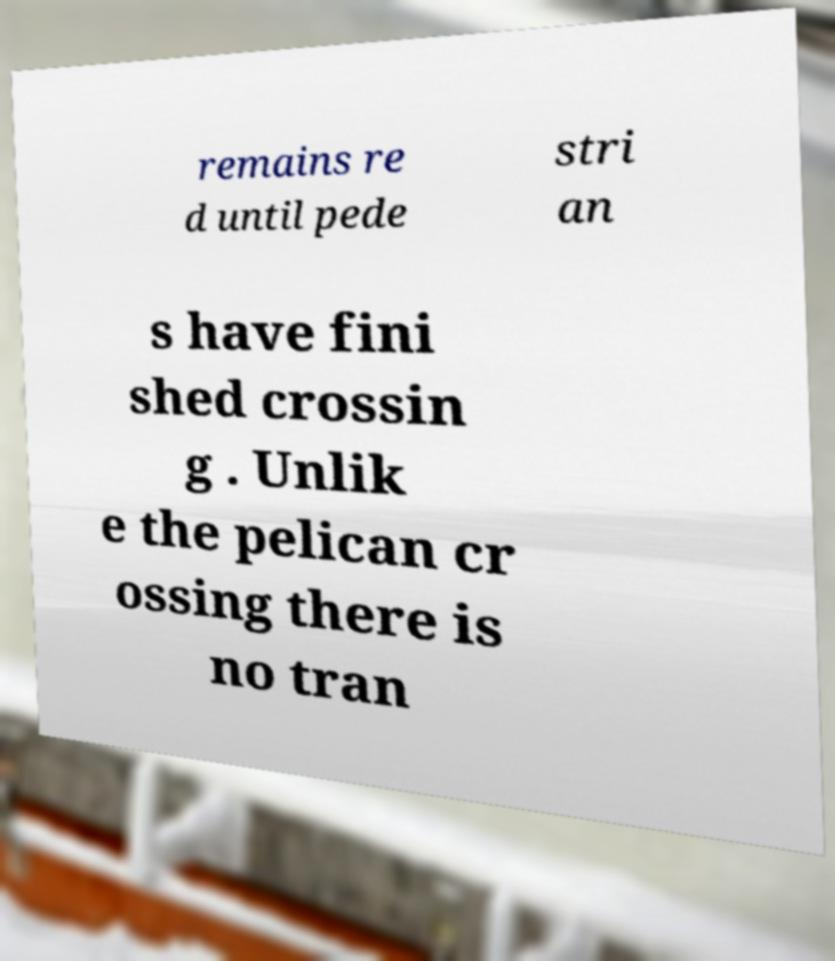For documentation purposes, I need the text within this image transcribed. Could you provide that? remains re d until pede stri an s have fini shed crossin g . Unlik e the pelican cr ossing there is no tran 